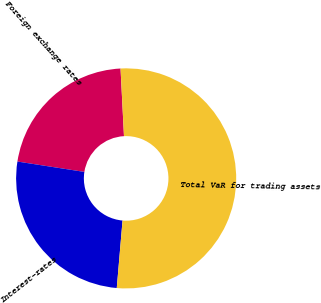<chart> <loc_0><loc_0><loc_500><loc_500><pie_chart><fcel>Foreign exchange rates<fcel>Interest-rates<fcel>Total VaR for trading assets<nl><fcel>21.74%<fcel>26.09%<fcel>52.17%<nl></chart> 